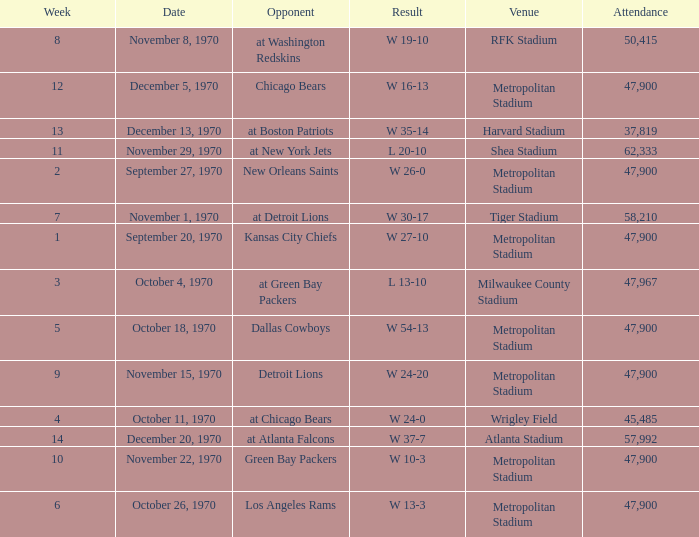How many people attended the game with a result of w 16-13 and a week earlier than 12? None. 